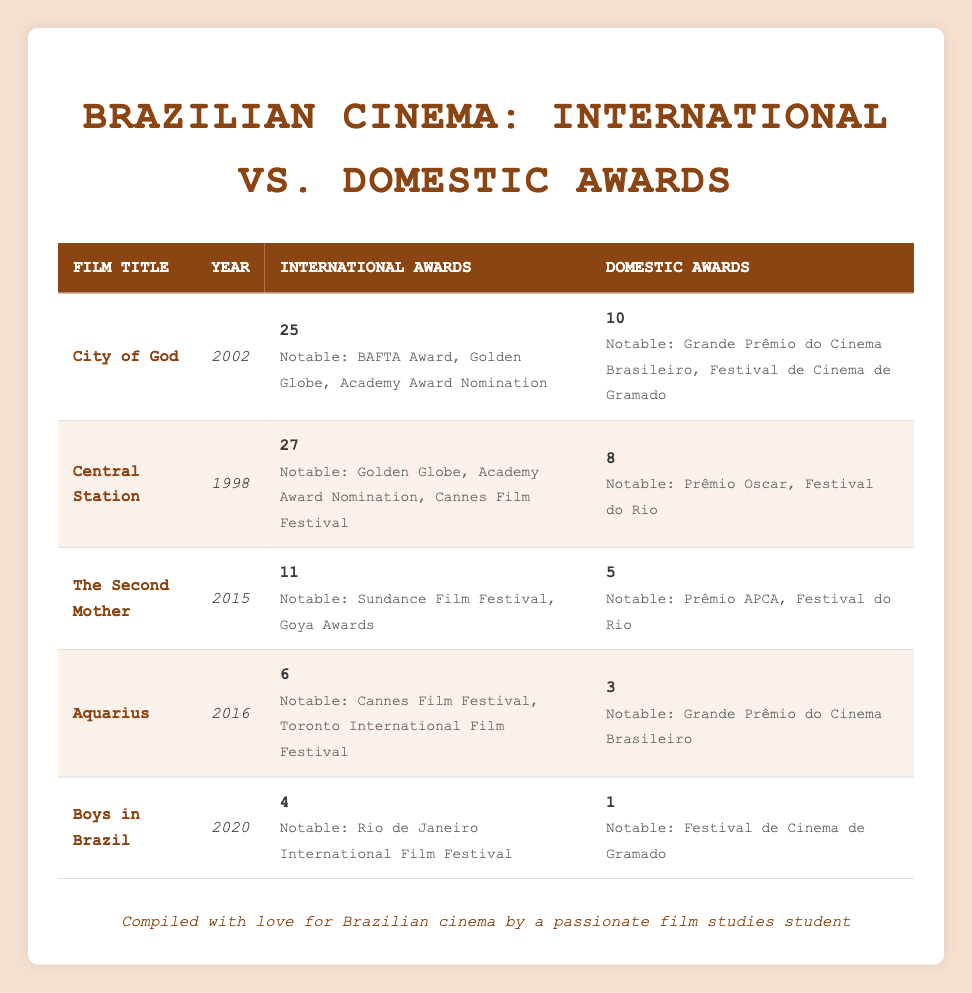What is the total number of international awards won by "City of God"? According to the table, "City of God" has won a total of 25 international awards.
Answer: 25 Which film won the fewest domestic awards? By examining the domestic awards column, "Boys in Brazil" won only 1 domestic award, which is the lowest among all films.
Answer: 1 What is the difference between the international and domestic awards for "Central Station"? "Central Station" won 27 international awards and 8 domestic awards. The difference is calculated as 27 - 8 = 19.
Answer: 19 Did "Aquarius" win more international awards than domestic awards? Yes, "Aquarius" won 6 international awards and 3 domestic awards. Since 6 is greater than 3, the answer is yes.
Answer: Yes What is the average number of international awards won by the films listed? To find the average, sum the international awards (25 + 27 + 11 + 6 + 4 = 73) and divide by the number of films (5). The average is 73 / 5 = 14.6.
Answer: 14.6 Which film had the highest ratio of international awards to domestic awards? To determine the highest ratio, calculate the ratio for each film: "City of God" (25/10 = 2.5), "Central Station" (27/8 = 3.375), "The Second Mother" (11/5 = 2.2), "Aquarius" (6/3 = 2), and "Boys in Brazil" (4/1 = 4). The highest ratio is 4 for "Boys in Brazil".
Answer: Boys in Brazil How many notable international awards did "The Second Mother" receive? The table lists "The Second Mother" received notable international awards at the Sundance Film Festival and Goya Awards, totaling 2 notable awards.
Answer: 2 What was the year of release for the film with the most international awards? By looking at the international awards, "Central Station" has the most with 27 awards, and it was released in 1998.
Answer: 1998 